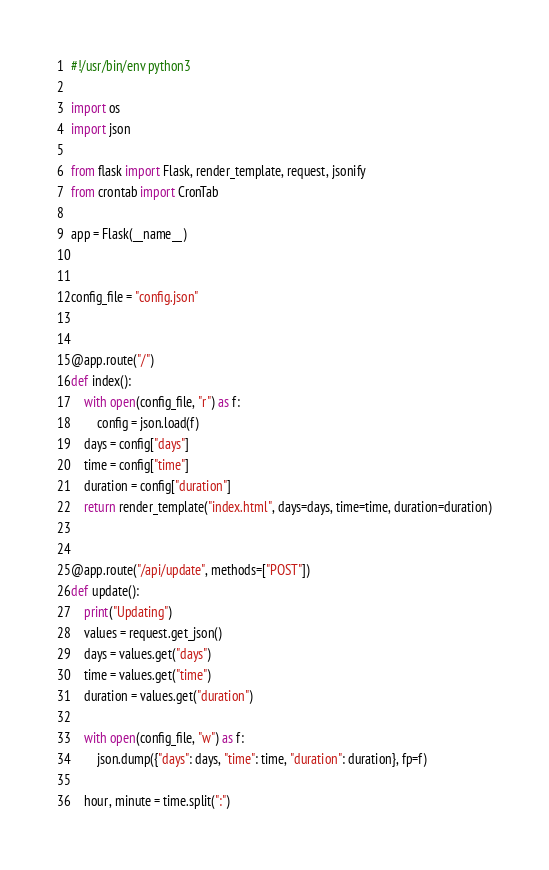Convert code to text. <code><loc_0><loc_0><loc_500><loc_500><_Python_>#!/usr/bin/env python3

import os
import json

from flask import Flask, render_template, request, jsonify
from crontab import CronTab

app = Flask(__name__)


config_file = "config.json"


@app.route("/")
def index():
    with open(config_file, "r") as f:
        config = json.load(f)
    days = config["days"]
    time = config["time"]
    duration = config["duration"]
    return render_template("index.html", days=days, time=time, duration=duration)


@app.route("/api/update", methods=["POST"])
def update():
    print("Updating")
    values = request.get_json()
    days = values.get("days")
    time = values.get("time")
    duration = values.get("duration")

    with open(config_file, "w") as f:
        json.dump({"days": days, "time": time, "duration": duration}, fp=f)

    hour, minute = time.split(":")
</code> 